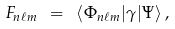Convert formula to latex. <formula><loc_0><loc_0><loc_500><loc_500>F _ { n \ell m } \ = \ \langle \Phi _ { n \ell m } | \gamma | \Psi \rangle \, ,</formula> 